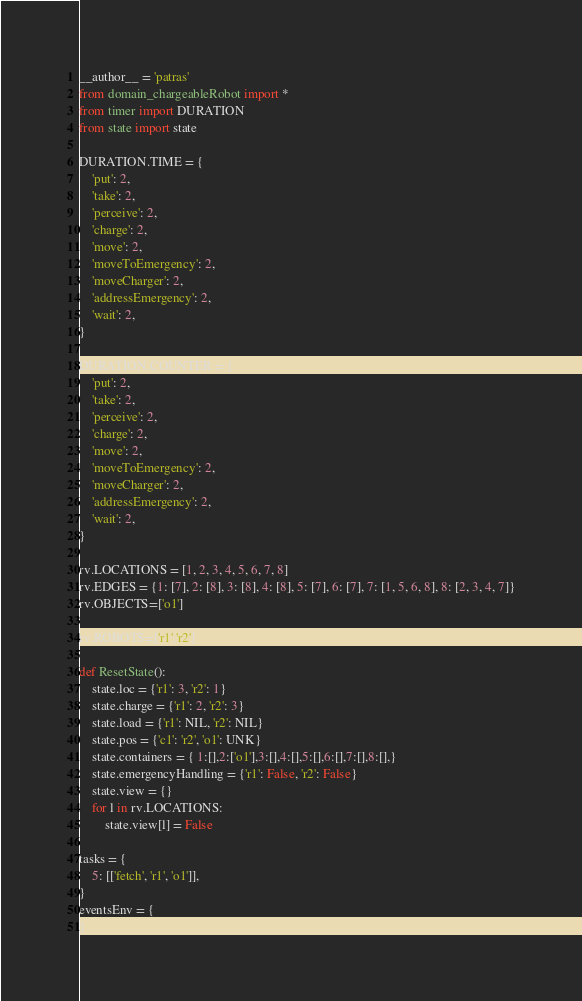<code> <loc_0><loc_0><loc_500><loc_500><_Python_>__author__ = 'patras'
from domain_chargeableRobot import *
from timer import DURATION
from state import state

DURATION.TIME = {
    'put': 2,
    'take': 2,
    'perceive': 2,
    'charge': 2,
    'move': 2,
    'moveToEmergency': 2,
    'moveCharger': 2,
    'addressEmergency': 2,
    'wait': 2,
}

DURATION.COUNTER = {
    'put': 2,
    'take': 2,
    'perceive': 2,
    'charge': 2,
    'move': 2,
    'moveToEmergency': 2,
    'moveCharger': 2,
    'addressEmergency': 2,
    'wait': 2,
}

rv.LOCATIONS = [1, 2, 3, 4, 5, 6, 7, 8]
rv.EDGES = {1: [7], 2: [8], 3: [8], 4: [8], 5: [7], 6: [7], 7: [1, 5, 6, 8], 8: [2, 3, 4, 7]}
rv.OBJECTS=['o1']

rv.ROBOTS=['r1','r2']

def ResetState():
    state.loc = {'r1': 3, 'r2': 1}
    state.charge = {'r1': 2, 'r2': 3}
    state.load = {'r1': NIL, 'r2': NIL}
    state.pos = {'c1': 'r2', 'o1': UNK}
    state.containers = { 1:[],2:['o1'],3:[],4:[],5:[],6:[],7:[],8:[],}
    state.emergencyHandling = {'r1': False, 'r2': False}
    state.view = {}
    for l in rv.LOCATIONS:
        state.view[l] = False

tasks = {
    5: [['fetch', 'r1', 'o1']],
}
eventsEnv = {
}</code> 